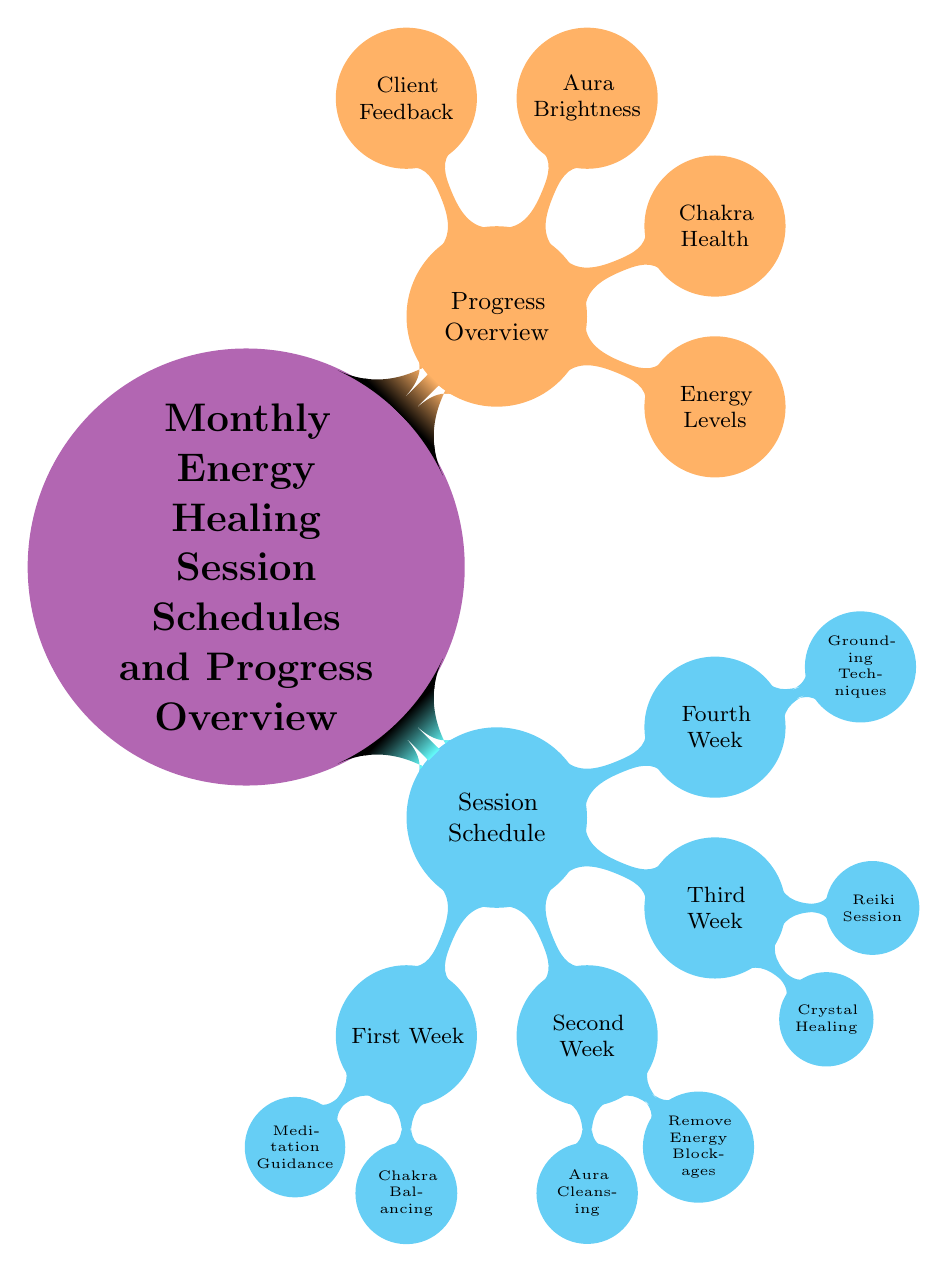What is the main theme of the diagram? The main theme is indicated by the root node, which is labeled "Monthly Energy Healing Session Schedules and Progress Overview." This establishes the overall focus of the diagram.
Answer: Monthly Energy Healing Session Schedules and Progress Overview How many sessions are outlined in the first week? The first week has two nodes branching from it: "Meditation Guidance" and "Chakra Balancing." Therefore, there are two sessions in the first week.
Answer: 2 What techniques are included in the second week's sessions? The second week has two child nodes: "Aura Cleansing" and "Remove Energy Blockages." These represent the techniques outlined for that week.
Answer: Aura Cleansing, Remove Energy Blockages How many categories are represented in the progress overview? There are four child nodes under the "Progress Overview" category: "Energy Levels," "Chakra Health," "Aura Brightness," and "Client Feedback." Counting these gives four categories total.
Answer: 4 Which week includes "Grounding Techniques"? "Grounding Techniques" is specifically mentioned as a child node of the fourth week, meaning it is included in that week's session activities.
Answer: Fourth Week Which session focuses on "Crystal Healing"? "Crystal Healing" is a session listed under the third week, as indicated by the child node structure of the diagram.
Answer: Third Week What is one of the factors tracked in the progress overview? From the progress overview section, we can see multiple factors, including "Energy Levels," which is directly cited as one of those being tracked.
Answer: Energy Levels Which color represents the session schedule in the diagram? The session schedule is represented by the cyan color, according to the formatting specified for the nodes in the diagram.
Answer: Cyan 